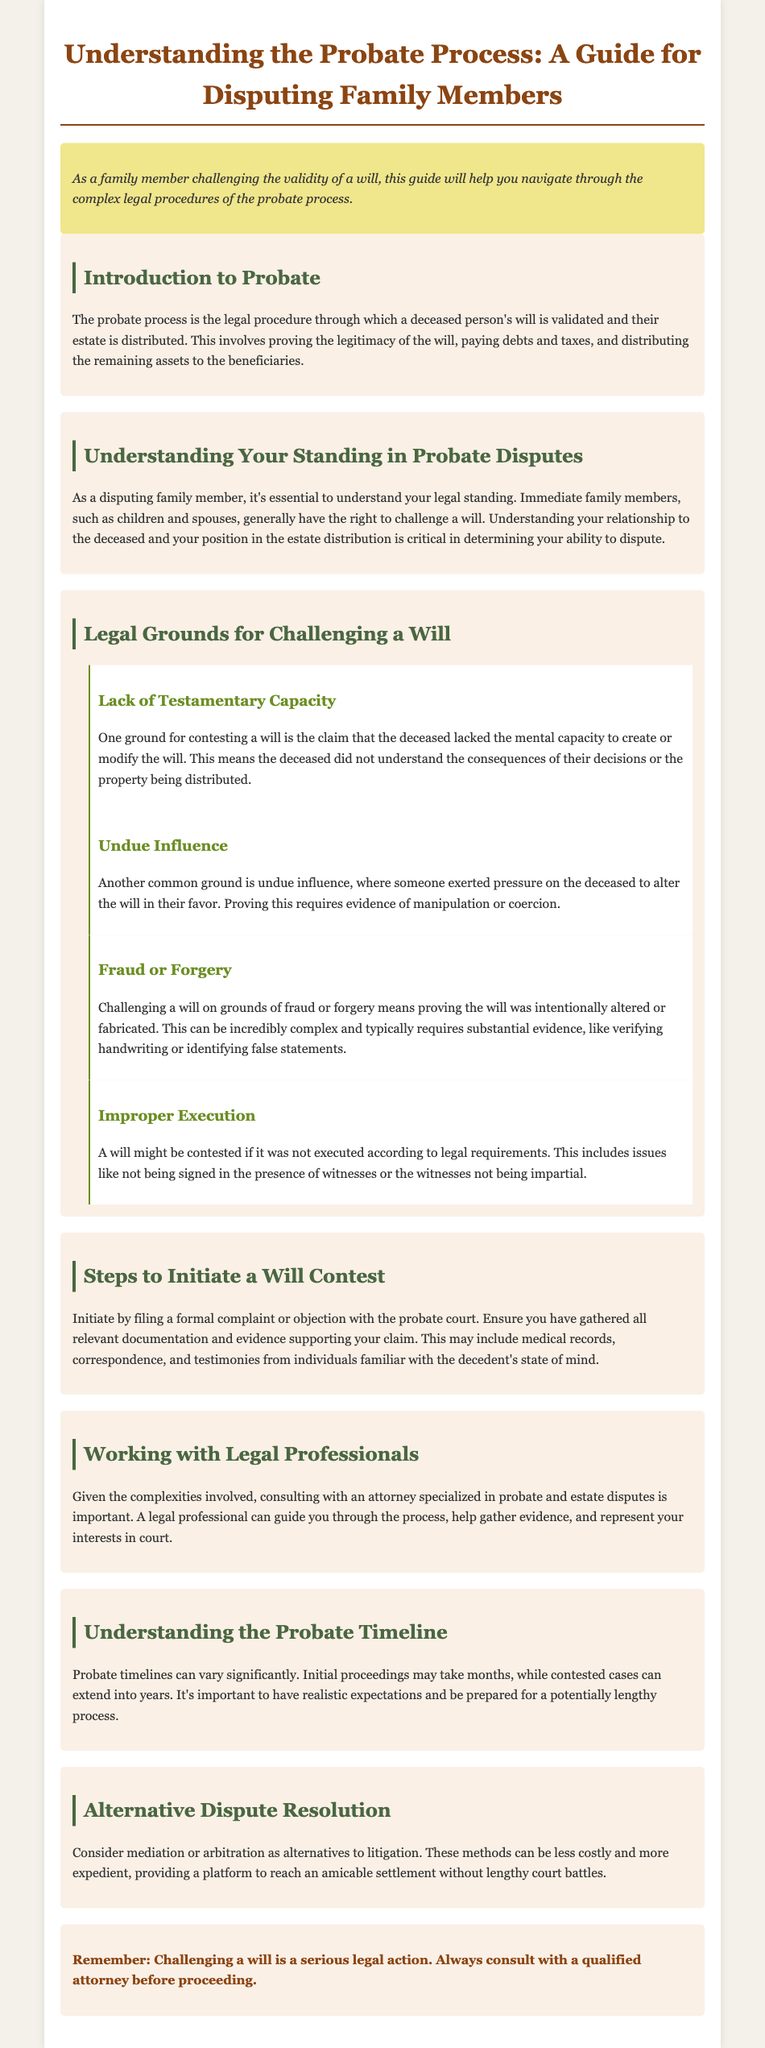what is the title of the document? The title is stated in the head section of the document as the main heading.
Answer: Understanding the Probate Process: A Guide for Disputing Family Members who generally has the right to challenge a will? The document indicates that immediate family members typically hold the right to initiate a challenge against a will.
Answer: Immediate family members name one ground for contesting a will. The document lists several grounds for contesting a will in a dedicated section and provides specific examples.
Answer: Lack of Testamentary Capacity how can you initiate a will contest? The initiation process is described as involving the filing of a formal complaint or objection with the probate court.
Answer: Filing a formal complaint which legal professional should you consult for probate disputes? The guide suggests seeking assistance from a specific type of attorney experienced in handling estate disputes.
Answer: Attorney specialized in probate what is one benefit of alternative dispute resolution? The document outlines alternative methods to litigation and highlights their advantages in comparison.
Answer: Less costly what should you be prepared for in terms of the probate timeline? The document addresses expectations regarding the duration of the probate process, indicating variability based on specific factors.
Answer: Lengthy process what type of document is this? The content is structured as an instructional resource aimed at a specific audience dealing with a particular legal situation.
Answer: User guide 